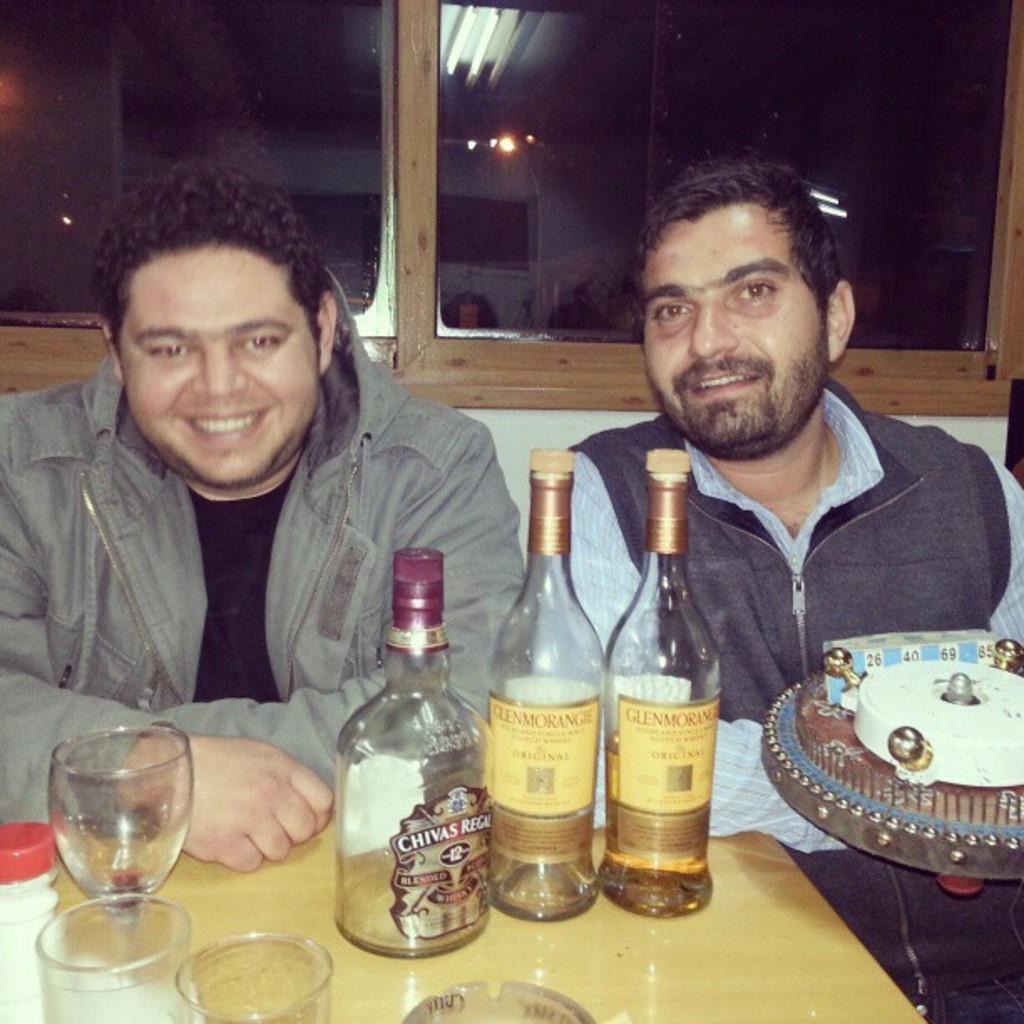Can you describe this image briefly? This two persons are sitting and holds smile. On this table there are bottles and glasses. This man is holding a toy. On this glass window there is a reflection of lights. 